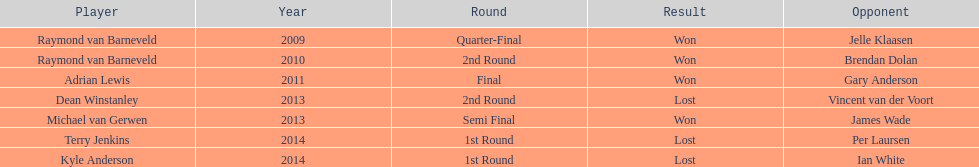Name a year with more than one game listed. 2013. 